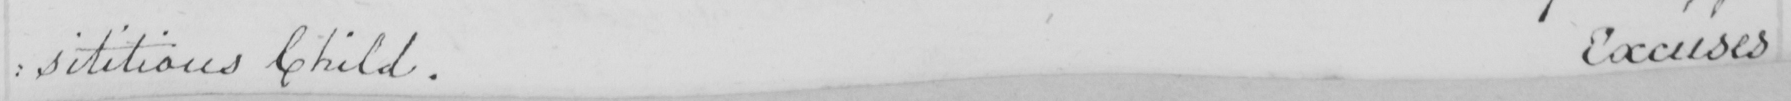What is written in this line of handwriting? : ssitious Child . Excuses 